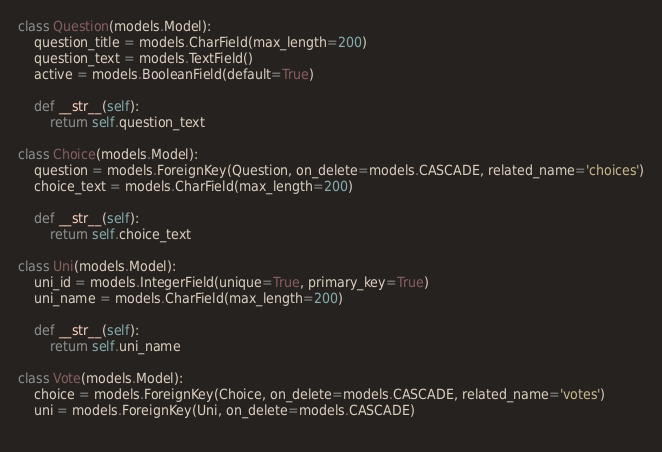Convert code to text. <code><loc_0><loc_0><loc_500><loc_500><_Python_>class Question(models.Model):
    question_title = models.CharField(max_length=200)
    question_text = models.TextField()
    active = models.BooleanField(default=True)

    def __str__(self):
        return self.question_text

class Choice(models.Model):
    question = models.ForeignKey(Question, on_delete=models.CASCADE, related_name='choices')
    choice_text = models.CharField(max_length=200)
    
    def __str__(self):
        return self.choice_text

class Uni(models.Model):
    uni_id = models.IntegerField(unique=True, primary_key=True)
    uni_name = models.CharField(max_length=200)
    
    def __str__(self):
        return self.uni_name

class Vote(models.Model):
    choice = models.ForeignKey(Choice, on_delete=models.CASCADE, related_name='votes')
    uni = models.ForeignKey(Uni, on_delete=models.CASCADE)
    
</code> 